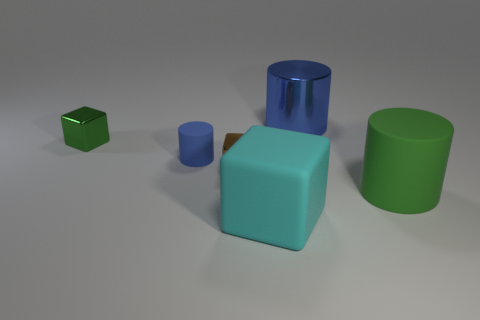Can you describe the lighting setup of this scene? The lighting of the scene suggests a diffused overhead source, as there are soft shadows extending from each object. There is an absence of harsh shadows or direct light reflections, which implies the light is not very intense or direct, and is possibly coming from a large source or is being filtered through a diffuser, creating this even, soft-lit environment. 